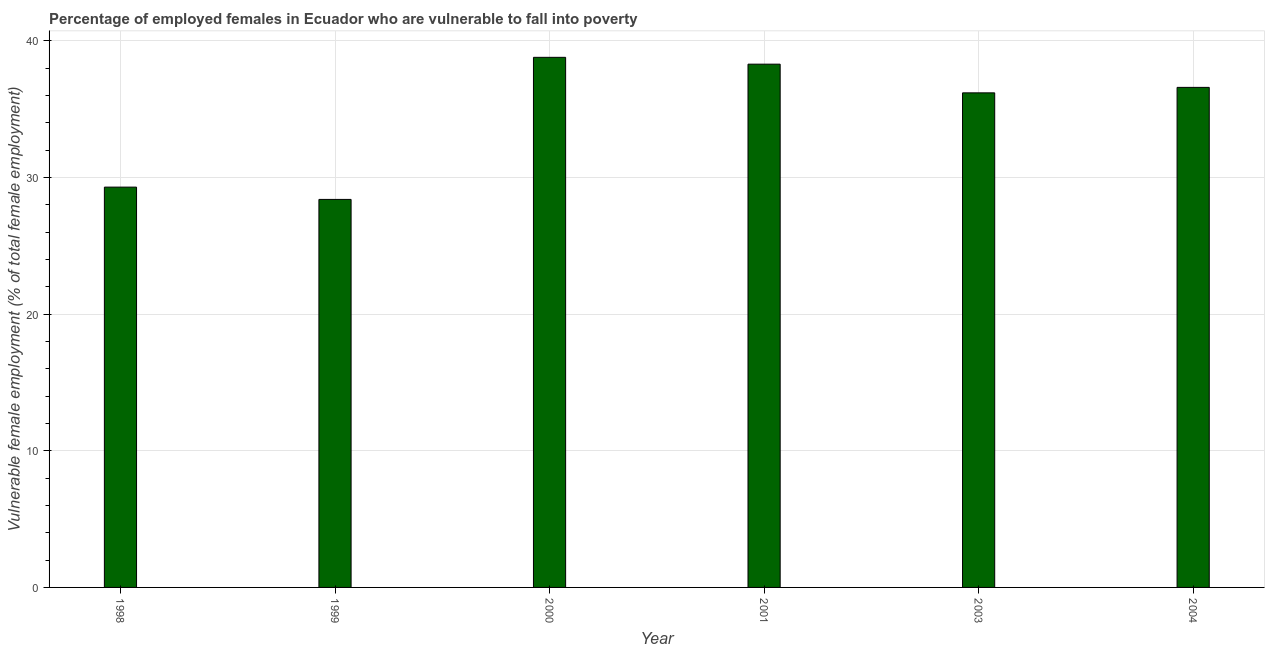What is the title of the graph?
Give a very brief answer. Percentage of employed females in Ecuador who are vulnerable to fall into poverty. What is the label or title of the Y-axis?
Ensure brevity in your answer.  Vulnerable female employment (% of total female employment). What is the percentage of employed females who are vulnerable to fall into poverty in 2003?
Your response must be concise. 36.2. Across all years, what is the maximum percentage of employed females who are vulnerable to fall into poverty?
Give a very brief answer. 38.8. Across all years, what is the minimum percentage of employed females who are vulnerable to fall into poverty?
Offer a very short reply. 28.4. In which year was the percentage of employed females who are vulnerable to fall into poverty maximum?
Keep it short and to the point. 2000. In which year was the percentage of employed females who are vulnerable to fall into poverty minimum?
Provide a succinct answer. 1999. What is the sum of the percentage of employed females who are vulnerable to fall into poverty?
Provide a succinct answer. 207.6. What is the average percentage of employed females who are vulnerable to fall into poverty per year?
Your answer should be very brief. 34.6. What is the median percentage of employed females who are vulnerable to fall into poverty?
Offer a terse response. 36.4. What is the ratio of the percentage of employed females who are vulnerable to fall into poverty in 1998 to that in 2004?
Make the answer very short. 0.8. Is the percentage of employed females who are vulnerable to fall into poverty in 1998 less than that in 2000?
Make the answer very short. Yes. What is the difference between the highest and the second highest percentage of employed females who are vulnerable to fall into poverty?
Provide a short and direct response. 0.5. What is the difference between the highest and the lowest percentage of employed females who are vulnerable to fall into poverty?
Your response must be concise. 10.4. How many bars are there?
Provide a succinct answer. 6. Are all the bars in the graph horizontal?
Ensure brevity in your answer.  No. How many years are there in the graph?
Provide a short and direct response. 6. What is the difference between two consecutive major ticks on the Y-axis?
Provide a short and direct response. 10. Are the values on the major ticks of Y-axis written in scientific E-notation?
Your answer should be very brief. No. What is the Vulnerable female employment (% of total female employment) of 1998?
Provide a succinct answer. 29.3. What is the Vulnerable female employment (% of total female employment) of 1999?
Give a very brief answer. 28.4. What is the Vulnerable female employment (% of total female employment) in 2000?
Give a very brief answer. 38.8. What is the Vulnerable female employment (% of total female employment) in 2001?
Give a very brief answer. 38.3. What is the Vulnerable female employment (% of total female employment) of 2003?
Offer a terse response. 36.2. What is the Vulnerable female employment (% of total female employment) in 2004?
Your answer should be very brief. 36.6. What is the difference between the Vulnerable female employment (% of total female employment) in 1998 and 1999?
Provide a short and direct response. 0.9. What is the difference between the Vulnerable female employment (% of total female employment) in 1998 and 2000?
Offer a terse response. -9.5. What is the difference between the Vulnerable female employment (% of total female employment) in 1998 and 2001?
Ensure brevity in your answer.  -9. What is the difference between the Vulnerable female employment (% of total female employment) in 1998 and 2003?
Ensure brevity in your answer.  -6.9. What is the difference between the Vulnerable female employment (% of total female employment) in 1998 and 2004?
Provide a short and direct response. -7.3. What is the difference between the Vulnerable female employment (% of total female employment) in 1999 and 2000?
Offer a very short reply. -10.4. What is the difference between the Vulnerable female employment (% of total female employment) in 1999 and 2004?
Your answer should be very brief. -8.2. What is the difference between the Vulnerable female employment (% of total female employment) in 2000 and 2001?
Provide a short and direct response. 0.5. What is the difference between the Vulnerable female employment (% of total female employment) in 2000 and 2003?
Your response must be concise. 2.6. What is the difference between the Vulnerable female employment (% of total female employment) in 2000 and 2004?
Keep it short and to the point. 2.2. What is the difference between the Vulnerable female employment (% of total female employment) in 2001 and 2003?
Offer a very short reply. 2.1. What is the difference between the Vulnerable female employment (% of total female employment) in 2001 and 2004?
Make the answer very short. 1.7. What is the difference between the Vulnerable female employment (% of total female employment) in 2003 and 2004?
Give a very brief answer. -0.4. What is the ratio of the Vulnerable female employment (% of total female employment) in 1998 to that in 1999?
Provide a succinct answer. 1.03. What is the ratio of the Vulnerable female employment (% of total female employment) in 1998 to that in 2000?
Offer a very short reply. 0.76. What is the ratio of the Vulnerable female employment (% of total female employment) in 1998 to that in 2001?
Offer a very short reply. 0.77. What is the ratio of the Vulnerable female employment (% of total female employment) in 1998 to that in 2003?
Your response must be concise. 0.81. What is the ratio of the Vulnerable female employment (% of total female employment) in 1998 to that in 2004?
Keep it short and to the point. 0.8. What is the ratio of the Vulnerable female employment (% of total female employment) in 1999 to that in 2000?
Provide a succinct answer. 0.73. What is the ratio of the Vulnerable female employment (% of total female employment) in 1999 to that in 2001?
Give a very brief answer. 0.74. What is the ratio of the Vulnerable female employment (% of total female employment) in 1999 to that in 2003?
Provide a short and direct response. 0.79. What is the ratio of the Vulnerable female employment (% of total female employment) in 1999 to that in 2004?
Your response must be concise. 0.78. What is the ratio of the Vulnerable female employment (% of total female employment) in 2000 to that in 2003?
Give a very brief answer. 1.07. What is the ratio of the Vulnerable female employment (% of total female employment) in 2000 to that in 2004?
Your answer should be compact. 1.06. What is the ratio of the Vulnerable female employment (% of total female employment) in 2001 to that in 2003?
Your response must be concise. 1.06. What is the ratio of the Vulnerable female employment (% of total female employment) in 2001 to that in 2004?
Provide a short and direct response. 1.05. 